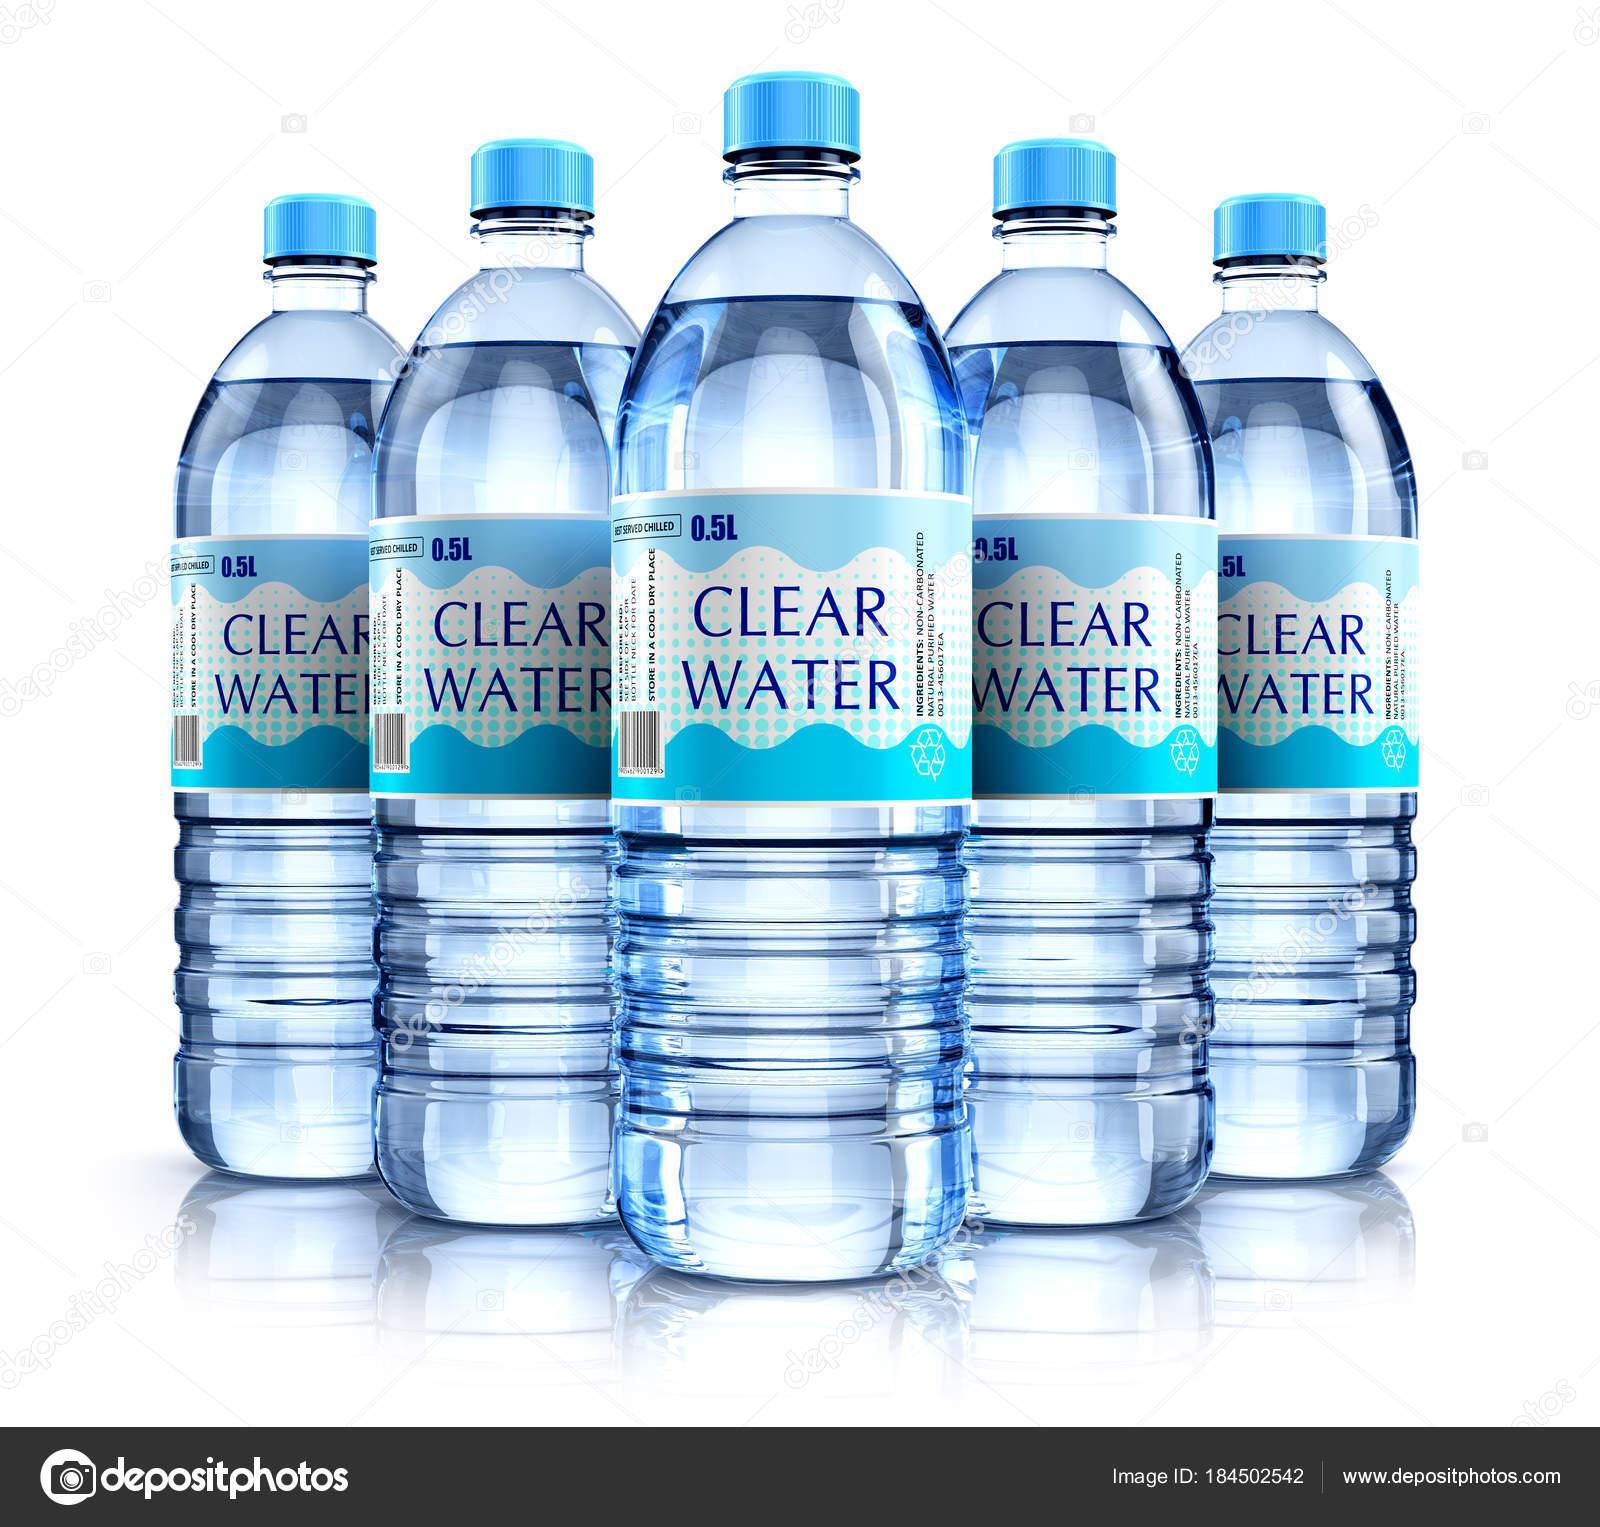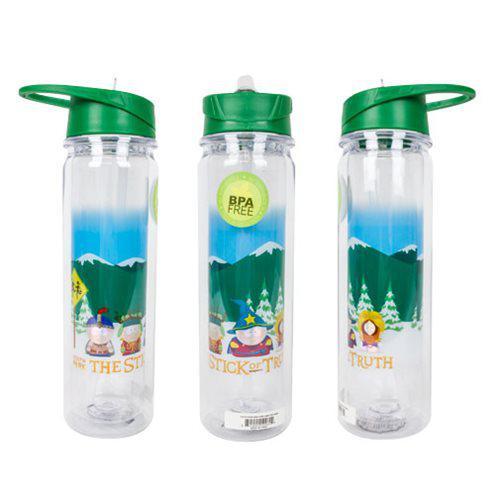The first image is the image on the left, the second image is the image on the right. Analyze the images presented: Is the assertion "The left image shows 5 water bottles lined up in V-formation with the words, """"clear water"""" on them." valid? Answer yes or no. Yes. The first image is the image on the left, the second image is the image on the right. Analyze the images presented: Is the assertion "Five identical water bottles are in a V-formation in the image on the left." valid? Answer yes or no. Yes. 